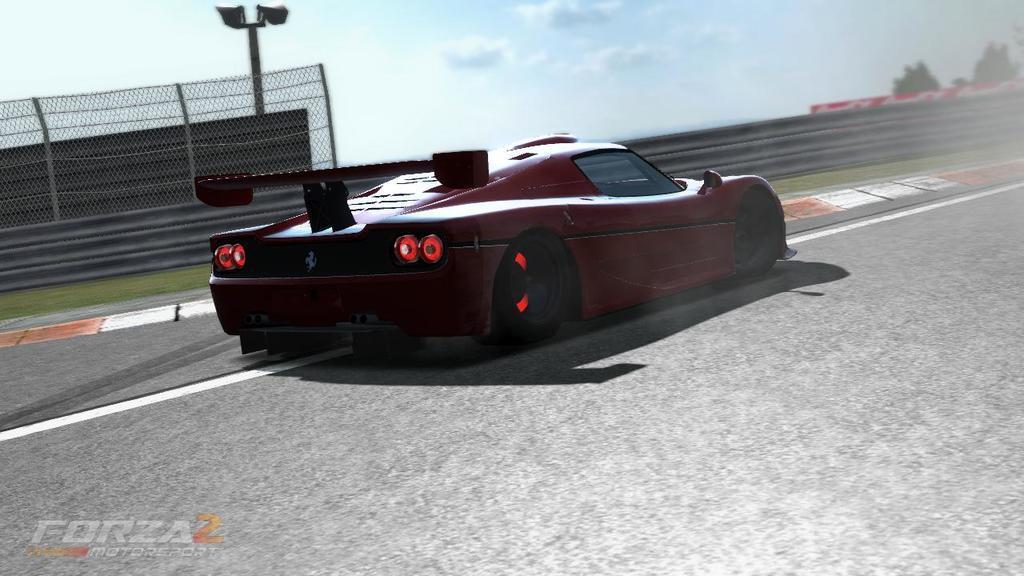Could you give a brief overview of what you see in this image? In this image I can see a car on the road. In the background, I can see the mesh and clouds in the sky. 